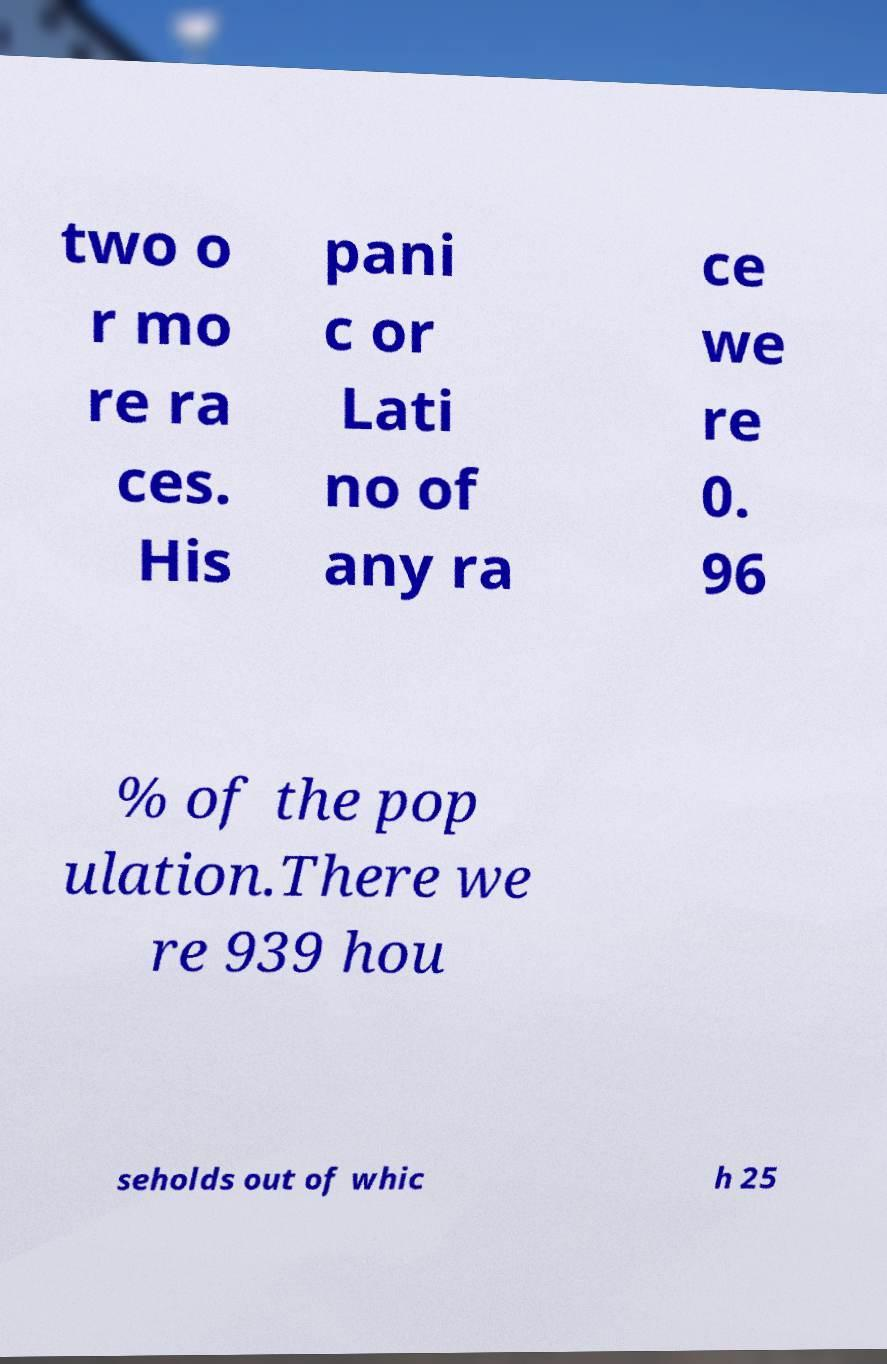Could you assist in decoding the text presented in this image and type it out clearly? two o r mo re ra ces. His pani c or Lati no of any ra ce we re 0. 96 % of the pop ulation.There we re 939 hou seholds out of whic h 25 